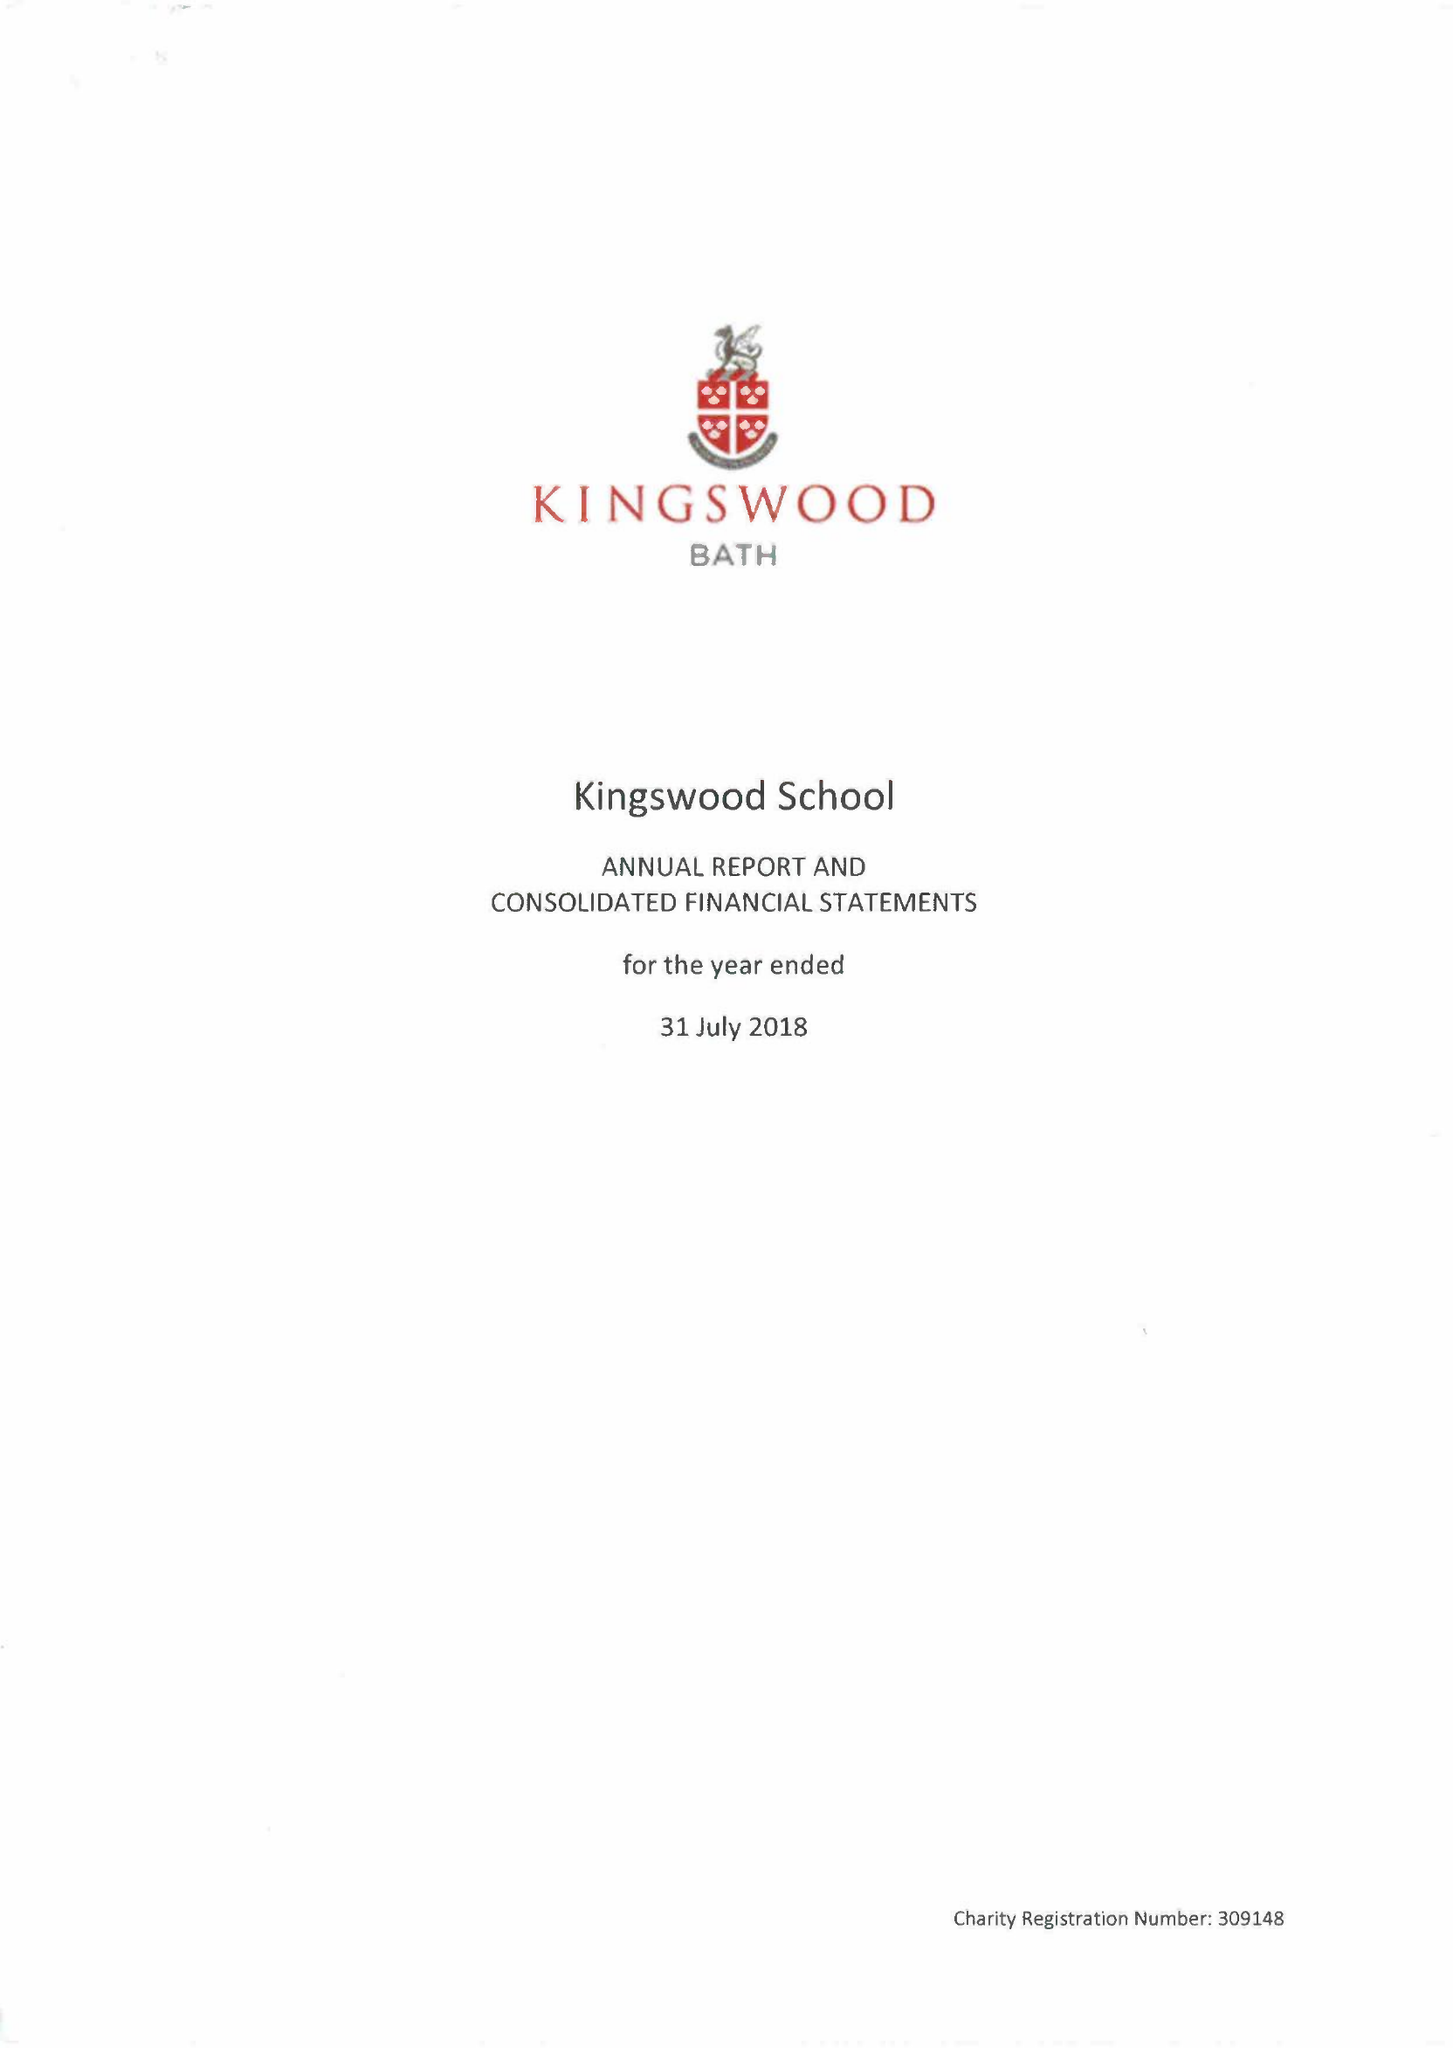What is the value for the charity_number?
Answer the question using a single word or phrase. 309148 